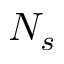<formula> <loc_0><loc_0><loc_500><loc_500>N _ { s }</formula> 